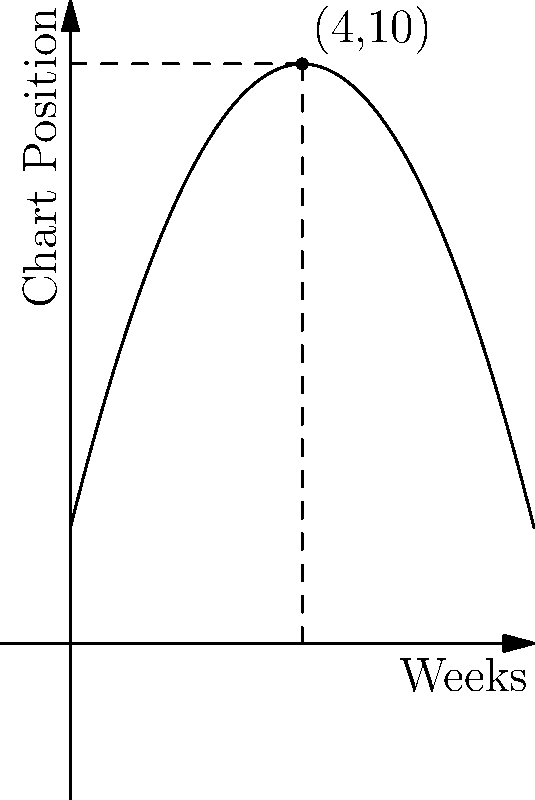The graph represents the chart position of a new pop song over 8 weeks. The function describing the chart position is $f(x) = -0.5x^2 + 4x + 2$, where $x$ is the number of weeks since release and $f(x)$ is the chart position. Find the equation of the tangent line to this curve at week 4. To find the equation of the tangent line, we need to follow these steps:

1) The general equation of a tangent line is $y - y_0 = m(x - x_0)$, where $(x_0, y_0)$ is the point of tangency and $m$ is the slope of the tangent line.

2) We know $x_0 = 4$. Let's find $y_0$:
   $y_0 = f(4) = -0.5(4)^2 + 4(4) + 2 = -8 + 16 + 2 = 10$
   So, the point of tangency is (4, 10).

3) To find the slope $m$, we need to calculate $f'(x)$ and then evaluate it at $x = 4$:
   $f'(x) = -x + 4$
   $f'(4) = -4 + 4 = 0$

4) Now we have all the components to write the equation of the tangent line:
   $y - 10 = 0(x - 4)$

5) Simplify:
   $y = 10$

This makes sense geometrically, as the tangent line at the highest point of a parabola is horizontal.
Answer: $y = 10$ 